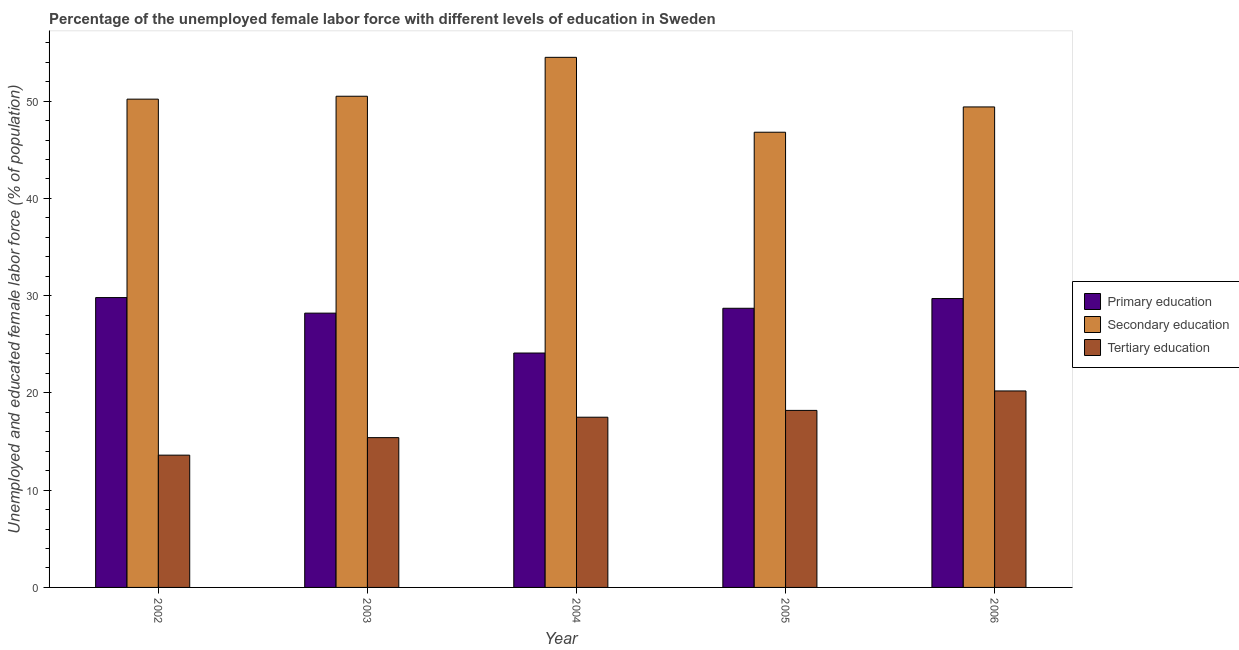How many different coloured bars are there?
Give a very brief answer. 3. How many groups of bars are there?
Provide a short and direct response. 5. Are the number of bars on each tick of the X-axis equal?
Ensure brevity in your answer.  Yes. How many bars are there on the 5th tick from the left?
Ensure brevity in your answer.  3. How many bars are there on the 4th tick from the right?
Make the answer very short. 3. What is the percentage of female labor force who received tertiary education in 2004?
Your response must be concise. 17.5. Across all years, what is the maximum percentage of female labor force who received secondary education?
Your answer should be very brief. 54.5. Across all years, what is the minimum percentage of female labor force who received tertiary education?
Ensure brevity in your answer.  13.6. In which year was the percentage of female labor force who received secondary education maximum?
Your answer should be compact. 2004. What is the total percentage of female labor force who received primary education in the graph?
Your answer should be very brief. 140.5. What is the difference between the percentage of female labor force who received tertiary education in 2003 and that in 2004?
Make the answer very short. -2.1. What is the difference between the percentage of female labor force who received primary education in 2006 and the percentage of female labor force who received tertiary education in 2004?
Your answer should be compact. 5.6. What is the average percentage of female labor force who received tertiary education per year?
Your answer should be compact. 16.98. In the year 2002, what is the difference between the percentage of female labor force who received secondary education and percentage of female labor force who received primary education?
Ensure brevity in your answer.  0. In how many years, is the percentage of female labor force who received primary education greater than 32 %?
Provide a succinct answer. 0. What is the ratio of the percentage of female labor force who received primary education in 2002 to that in 2003?
Your response must be concise. 1.06. What is the difference between the highest and the second highest percentage of female labor force who received tertiary education?
Your answer should be compact. 2. What is the difference between the highest and the lowest percentage of female labor force who received secondary education?
Offer a terse response. 7.7. What does the 3rd bar from the left in 2004 represents?
Your answer should be very brief. Tertiary education. What does the 2nd bar from the right in 2004 represents?
Offer a very short reply. Secondary education. How many bars are there?
Offer a very short reply. 15. What is the difference between two consecutive major ticks on the Y-axis?
Give a very brief answer. 10. Does the graph contain any zero values?
Your answer should be very brief. No. Where does the legend appear in the graph?
Provide a succinct answer. Center right. How many legend labels are there?
Your response must be concise. 3. How are the legend labels stacked?
Ensure brevity in your answer.  Vertical. What is the title of the graph?
Offer a very short reply. Percentage of the unemployed female labor force with different levels of education in Sweden. What is the label or title of the X-axis?
Make the answer very short. Year. What is the label or title of the Y-axis?
Offer a terse response. Unemployed and educated female labor force (% of population). What is the Unemployed and educated female labor force (% of population) of Primary education in 2002?
Give a very brief answer. 29.8. What is the Unemployed and educated female labor force (% of population) in Secondary education in 2002?
Offer a terse response. 50.2. What is the Unemployed and educated female labor force (% of population) in Tertiary education in 2002?
Make the answer very short. 13.6. What is the Unemployed and educated female labor force (% of population) in Primary education in 2003?
Provide a succinct answer. 28.2. What is the Unemployed and educated female labor force (% of population) of Secondary education in 2003?
Offer a very short reply. 50.5. What is the Unemployed and educated female labor force (% of population) in Tertiary education in 2003?
Ensure brevity in your answer.  15.4. What is the Unemployed and educated female labor force (% of population) in Primary education in 2004?
Give a very brief answer. 24.1. What is the Unemployed and educated female labor force (% of population) in Secondary education in 2004?
Make the answer very short. 54.5. What is the Unemployed and educated female labor force (% of population) in Primary education in 2005?
Your response must be concise. 28.7. What is the Unemployed and educated female labor force (% of population) in Secondary education in 2005?
Give a very brief answer. 46.8. What is the Unemployed and educated female labor force (% of population) in Tertiary education in 2005?
Ensure brevity in your answer.  18.2. What is the Unemployed and educated female labor force (% of population) of Primary education in 2006?
Make the answer very short. 29.7. What is the Unemployed and educated female labor force (% of population) of Secondary education in 2006?
Your response must be concise. 49.4. What is the Unemployed and educated female labor force (% of population) of Tertiary education in 2006?
Your answer should be compact. 20.2. Across all years, what is the maximum Unemployed and educated female labor force (% of population) of Primary education?
Provide a short and direct response. 29.8. Across all years, what is the maximum Unemployed and educated female labor force (% of population) of Secondary education?
Ensure brevity in your answer.  54.5. Across all years, what is the maximum Unemployed and educated female labor force (% of population) in Tertiary education?
Keep it short and to the point. 20.2. Across all years, what is the minimum Unemployed and educated female labor force (% of population) in Primary education?
Your answer should be very brief. 24.1. Across all years, what is the minimum Unemployed and educated female labor force (% of population) of Secondary education?
Make the answer very short. 46.8. Across all years, what is the minimum Unemployed and educated female labor force (% of population) in Tertiary education?
Keep it short and to the point. 13.6. What is the total Unemployed and educated female labor force (% of population) in Primary education in the graph?
Your response must be concise. 140.5. What is the total Unemployed and educated female labor force (% of population) of Secondary education in the graph?
Ensure brevity in your answer.  251.4. What is the total Unemployed and educated female labor force (% of population) of Tertiary education in the graph?
Offer a very short reply. 84.9. What is the difference between the Unemployed and educated female labor force (% of population) of Primary education in 2002 and that in 2003?
Ensure brevity in your answer.  1.6. What is the difference between the Unemployed and educated female labor force (% of population) in Secondary education in 2002 and that in 2003?
Your response must be concise. -0.3. What is the difference between the Unemployed and educated female labor force (% of population) in Primary education in 2002 and that in 2004?
Provide a succinct answer. 5.7. What is the difference between the Unemployed and educated female labor force (% of population) in Tertiary education in 2002 and that in 2004?
Provide a succinct answer. -3.9. What is the difference between the Unemployed and educated female labor force (% of population) of Primary education in 2002 and that in 2005?
Your answer should be compact. 1.1. What is the difference between the Unemployed and educated female labor force (% of population) of Secondary education in 2002 and that in 2005?
Provide a short and direct response. 3.4. What is the difference between the Unemployed and educated female labor force (% of population) of Tertiary education in 2002 and that in 2005?
Offer a very short reply. -4.6. What is the difference between the Unemployed and educated female labor force (% of population) of Primary education in 2002 and that in 2006?
Offer a terse response. 0.1. What is the difference between the Unemployed and educated female labor force (% of population) in Secondary education in 2002 and that in 2006?
Keep it short and to the point. 0.8. What is the difference between the Unemployed and educated female labor force (% of population) in Tertiary education in 2002 and that in 2006?
Your answer should be very brief. -6.6. What is the difference between the Unemployed and educated female labor force (% of population) in Secondary education in 2003 and that in 2004?
Your answer should be compact. -4. What is the difference between the Unemployed and educated female labor force (% of population) in Primary education in 2003 and that in 2005?
Keep it short and to the point. -0.5. What is the difference between the Unemployed and educated female labor force (% of population) in Tertiary education in 2003 and that in 2005?
Your answer should be very brief. -2.8. What is the difference between the Unemployed and educated female labor force (% of population) in Tertiary education in 2003 and that in 2006?
Offer a terse response. -4.8. What is the difference between the Unemployed and educated female labor force (% of population) of Secondary education in 2004 and that in 2005?
Your response must be concise. 7.7. What is the difference between the Unemployed and educated female labor force (% of population) in Tertiary education in 2004 and that in 2005?
Provide a short and direct response. -0.7. What is the difference between the Unemployed and educated female labor force (% of population) of Primary education in 2004 and that in 2006?
Your answer should be very brief. -5.6. What is the difference between the Unemployed and educated female labor force (% of population) in Secondary education in 2004 and that in 2006?
Your answer should be very brief. 5.1. What is the difference between the Unemployed and educated female labor force (% of population) in Tertiary education in 2004 and that in 2006?
Provide a succinct answer. -2.7. What is the difference between the Unemployed and educated female labor force (% of population) of Secondary education in 2005 and that in 2006?
Make the answer very short. -2.6. What is the difference between the Unemployed and educated female labor force (% of population) of Primary education in 2002 and the Unemployed and educated female labor force (% of population) of Secondary education in 2003?
Offer a terse response. -20.7. What is the difference between the Unemployed and educated female labor force (% of population) of Primary education in 2002 and the Unemployed and educated female labor force (% of population) of Tertiary education in 2003?
Provide a succinct answer. 14.4. What is the difference between the Unemployed and educated female labor force (% of population) in Secondary education in 2002 and the Unemployed and educated female labor force (% of population) in Tertiary education in 2003?
Give a very brief answer. 34.8. What is the difference between the Unemployed and educated female labor force (% of population) in Primary education in 2002 and the Unemployed and educated female labor force (% of population) in Secondary education in 2004?
Provide a succinct answer. -24.7. What is the difference between the Unemployed and educated female labor force (% of population) of Primary education in 2002 and the Unemployed and educated female labor force (% of population) of Tertiary education in 2004?
Provide a succinct answer. 12.3. What is the difference between the Unemployed and educated female labor force (% of population) in Secondary education in 2002 and the Unemployed and educated female labor force (% of population) in Tertiary education in 2004?
Your answer should be very brief. 32.7. What is the difference between the Unemployed and educated female labor force (% of population) of Primary education in 2002 and the Unemployed and educated female labor force (% of population) of Secondary education in 2005?
Offer a terse response. -17. What is the difference between the Unemployed and educated female labor force (% of population) in Primary education in 2002 and the Unemployed and educated female labor force (% of population) in Secondary education in 2006?
Provide a short and direct response. -19.6. What is the difference between the Unemployed and educated female labor force (% of population) of Primary education in 2002 and the Unemployed and educated female labor force (% of population) of Tertiary education in 2006?
Give a very brief answer. 9.6. What is the difference between the Unemployed and educated female labor force (% of population) in Primary education in 2003 and the Unemployed and educated female labor force (% of population) in Secondary education in 2004?
Your answer should be compact. -26.3. What is the difference between the Unemployed and educated female labor force (% of population) in Secondary education in 2003 and the Unemployed and educated female labor force (% of population) in Tertiary education in 2004?
Give a very brief answer. 33. What is the difference between the Unemployed and educated female labor force (% of population) in Primary education in 2003 and the Unemployed and educated female labor force (% of population) in Secondary education in 2005?
Keep it short and to the point. -18.6. What is the difference between the Unemployed and educated female labor force (% of population) of Primary education in 2003 and the Unemployed and educated female labor force (% of population) of Tertiary education in 2005?
Provide a short and direct response. 10. What is the difference between the Unemployed and educated female labor force (% of population) of Secondary education in 2003 and the Unemployed and educated female labor force (% of population) of Tertiary education in 2005?
Your response must be concise. 32.3. What is the difference between the Unemployed and educated female labor force (% of population) in Primary education in 2003 and the Unemployed and educated female labor force (% of population) in Secondary education in 2006?
Your response must be concise. -21.2. What is the difference between the Unemployed and educated female labor force (% of population) of Primary education in 2003 and the Unemployed and educated female labor force (% of population) of Tertiary education in 2006?
Keep it short and to the point. 8. What is the difference between the Unemployed and educated female labor force (% of population) in Secondary education in 2003 and the Unemployed and educated female labor force (% of population) in Tertiary education in 2006?
Your response must be concise. 30.3. What is the difference between the Unemployed and educated female labor force (% of population) in Primary education in 2004 and the Unemployed and educated female labor force (% of population) in Secondary education in 2005?
Make the answer very short. -22.7. What is the difference between the Unemployed and educated female labor force (% of population) of Primary education in 2004 and the Unemployed and educated female labor force (% of population) of Tertiary education in 2005?
Your response must be concise. 5.9. What is the difference between the Unemployed and educated female labor force (% of population) in Secondary education in 2004 and the Unemployed and educated female labor force (% of population) in Tertiary education in 2005?
Offer a terse response. 36.3. What is the difference between the Unemployed and educated female labor force (% of population) of Primary education in 2004 and the Unemployed and educated female labor force (% of population) of Secondary education in 2006?
Provide a short and direct response. -25.3. What is the difference between the Unemployed and educated female labor force (% of population) of Primary education in 2004 and the Unemployed and educated female labor force (% of population) of Tertiary education in 2006?
Provide a succinct answer. 3.9. What is the difference between the Unemployed and educated female labor force (% of population) in Secondary education in 2004 and the Unemployed and educated female labor force (% of population) in Tertiary education in 2006?
Make the answer very short. 34.3. What is the difference between the Unemployed and educated female labor force (% of population) in Primary education in 2005 and the Unemployed and educated female labor force (% of population) in Secondary education in 2006?
Provide a short and direct response. -20.7. What is the difference between the Unemployed and educated female labor force (% of population) in Secondary education in 2005 and the Unemployed and educated female labor force (% of population) in Tertiary education in 2006?
Offer a terse response. 26.6. What is the average Unemployed and educated female labor force (% of population) of Primary education per year?
Your answer should be very brief. 28.1. What is the average Unemployed and educated female labor force (% of population) of Secondary education per year?
Give a very brief answer. 50.28. What is the average Unemployed and educated female labor force (% of population) in Tertiary education per year?
Your answer should be compact. 16.98. In the year 2002, what is the difference between the Unemployed and educated female labor force (% of population) of Primary education and Unemployed and educated female labor force (% of population) of Secondary education?
Provide a succinct answer. -20.4. In the year 2002, what is the difference between the Unemployed and educated female labor force (% of population) in Primary education and Unemployed and educated female labor force (% of population) in Tertiary education?
Make the answer very short. 16.2. In the year 2002, what is the difference between the Unemployed and educated female labor force (% of population) in Secondary education and Unemployed and educated female labor force (% of population) in Tertiary education?
Your answer should be very brief. 36.6. In the year 2003, what is the difference between the Unemployed and educated female labor force (% of population) in Primary education and Unemployed and educated female labor force (% of population) in Secondary education?
Your answer should be very brief. -22.3. In the year 2003, what is the difference between the Unemployed and educated female labor force (% of population) of Secondary education and Unemployed and educated female labor force (% of population) of Tertiary education?
Your answer should be compact. 35.1. In the year 2004, what is the difference between the Unemployed and educated female labor force (% of population) in Primary education and Unemployed and educated female labor force (% of population) in Secondary education?
Keep it short and to the point. -30.4. In the year 2004, what is the difference between the Unemployed and educated female labor force (% of population) in Primary education and Unemployed and educated female labor force (% of population) in Tertiary education?
Give a very brief answer. 6.6. In the year 2005, what is the difference between the Unemployed and educated female labor force (% of population) in Primary education and Unemployed and educated female labor force (% of population) in Secondary education?
Make the answer very short. -18.1. In the year 2005, what is the difference between the Unemployed and educated female labor force (% of population) in Primary education and Unemployed and educated female labor force (% of population) in Tertiary education?
Ensure brevity in your answer.  10.5. In the year 2005, what is the difference between the Unemployed and educated female labor force (% of population) of Secondary education and Unemployed and educated female labor force (% of population) of Tertiary education?
Make the answer very short. 28.6. In the year 2006, what is the difference between the Unemployed and educated female labor force (% of population) of Primary education and Unemployed and educated female labor force (% of population) of Secondary education?
Offer a very short reply. -19.7. In the year 2006, what is the difference between the Unemployed and educated female labor force (% of population) of Secondary education and Unemployed and educated female labor force (% of population) of Tertiary education?
Provide a succinct answer. 29.2. What is the ratio of the Unemployed and educated female labor force (% of population) of Primary education in 2002 to that in 2003?
Offer a terse response. 1.06. What is the ratio of the Unemployed and educated female labor force (% of population) in Secondary education in 2002 to that in 2003?
Provide a short and direct response. 0.99. What is the ratio of the Unemployed and educated female labor force (% of population) in Tertiary education in 2002 to that in 2003?
Offer a terse response. 0.88. What is the ratio of the Unemployed and educated female labor force (% of population) of Primary education in 2002 to that in 2004?
Offer a terse response. 1.24. What is the ratio of the Unemployed and educated female labor force (% of population) in Secondary education in 2002 to that in 2004?
Give a very brief answer. 0.92. What is the ratio of the Unemployed and educated female labor force (% of population) in Tertiary education in 2002 to that in 2004?
Your response must be concise. 0.78. What is the ratio of the Unemployed and educated female labor force (% of population) in Primary education in 2002 to that in 2005?
Offer a terse response. 1.04. What is the ratio of the Unemployed and educated female labor force (% of population) of Secondary education in 2002 to that in 2005?
Keep it short and to the point. 1.07. What is the ratio of the Unemployed and educated female labor force (% of population) of Tertiary education in 2002 to that in 2005?
Give a very brief answer. 0.75. What is the ratio of the Unemployed and educated female labor force (% of population) in Secondary education in 2002 to that in 2006?
Make the answer very short. 1.02. What is the ratio of the Unemployed and educated female labor force (% of population) in Tertiary education in 2002 to that in 2006?
Make the answer very short. 0.67. What is the ratio of the Unemployed and educated female labor force (% of population) in Primary education in 2003 to that in 2004?
Offer a very short reply. 1.17. What is the ratio of the Unemployed and educated female labor force (% of population) of Secondary education in 2003 to that in 2004?
Your answer should be very brief. 0.93. What is the ratio of the Unemployed and educated female labor force (% of population) of Tertiary education in 2003 to that in 2004?
Offer a very short reply. 0.88. What is the ratio of the Unemployed and educated female labor force (% of population) in Primary education in 2003 to that in 2005?
Your answer should be very brief. 0.98. What is the ratio of the Unemployed and educated female labor force (% of population) in Secondary education in 2003 to that in 2005?
Your response must be concise. 1.08. What is the ratio of the Unemployed and educated female labor force (% of population) of Tertiary education in 2003 to that in 2005?
Give a very brief answer. 0.85. What is the ratio of the Unemployed and educated female labor force (% of population) of Primary education in 2003 to that in 2006?
Provide a short and direct response. 0.95. What is the ratio of the Unemployed and educated female labor force (% of population) of Secondary education in 2003 to that in 2006?
Offer a terse response. 1.02. What is the ratio of the Unemployed and educated female labor force (% of population) in Tertiary education in 2003 to that in 2006?
Offer a terse response. 0.76. What is the ratio of the Unemployed and educated female labor force (% of population) of Primary education in 2004 to that in 2005?
Your response must be concise. 0.84. What is the ratio of the Unemployed and educated female labor force (% of population) in Secondary education in 2004 to that in 2005?
Ensure brevity in your answer.  1.16. What is the ratio of the Unemployed and educated female labor force (% of population) in Tertiary education in 2004 to that in 2005?
Offer a terse response. 0.96. What is the ratio of the Unemployed and educated female labor force (% of population) of Primary education in 2004 to that in 2006?
Your answer should be compact. 0.81. What is the ratio of the Unemployed and educated female labor force (% of population) in Secondary education in 2004 to that in 2006?
Your answer should be very brief. 1.1. What is the ratio of the Unemployed and educated female labor force (% of population) in Tertiary education in 2004 to that in 2006?
Ensure brevity in your answer.  0.87. What is the ratio of the Unemployed and educated female labor force (% of population) in Primary education in 2005 to that in 2006?
Make the answer very short. 0.97. What is the ratio of the Unemployed and educated female labor force (% of population) of Tertiary education in 2005 to that in 2006?
Offer a very short reply. 0.9. What is the difference between the highest and the second highest Unemployed and educated female labor force (% of population) of Secondary education?
Provide a short and direct response. 4. What is the difference between the highest and the second highest Unemployed and educated female labor force (% of population) in Tertiary education?
Give a very brief answer. 2. What is the difference between the highest and the lowest Unemployed and educated female labor force (% of population) in Primary education?
Your answer should be very brief. 5.7. 